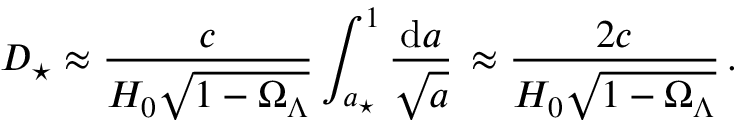Convert formula to latex. <formula><loc_0><loc_0><loc_500><loc_500>D _ { ^ { * } } \approx \frac { c } { H _ { 0 } \sqrt { 1 - \Omega _ { \Lambda } } } \int _ { a _ { ^ { * } } } ^ { 1 } \frac { d a } { \sqrt { a } } \, \approx \frac { 2 c } { H _ { 0 } \sqrt { 1 - \Omega _ { \Lambda } } } \, .</formula> 